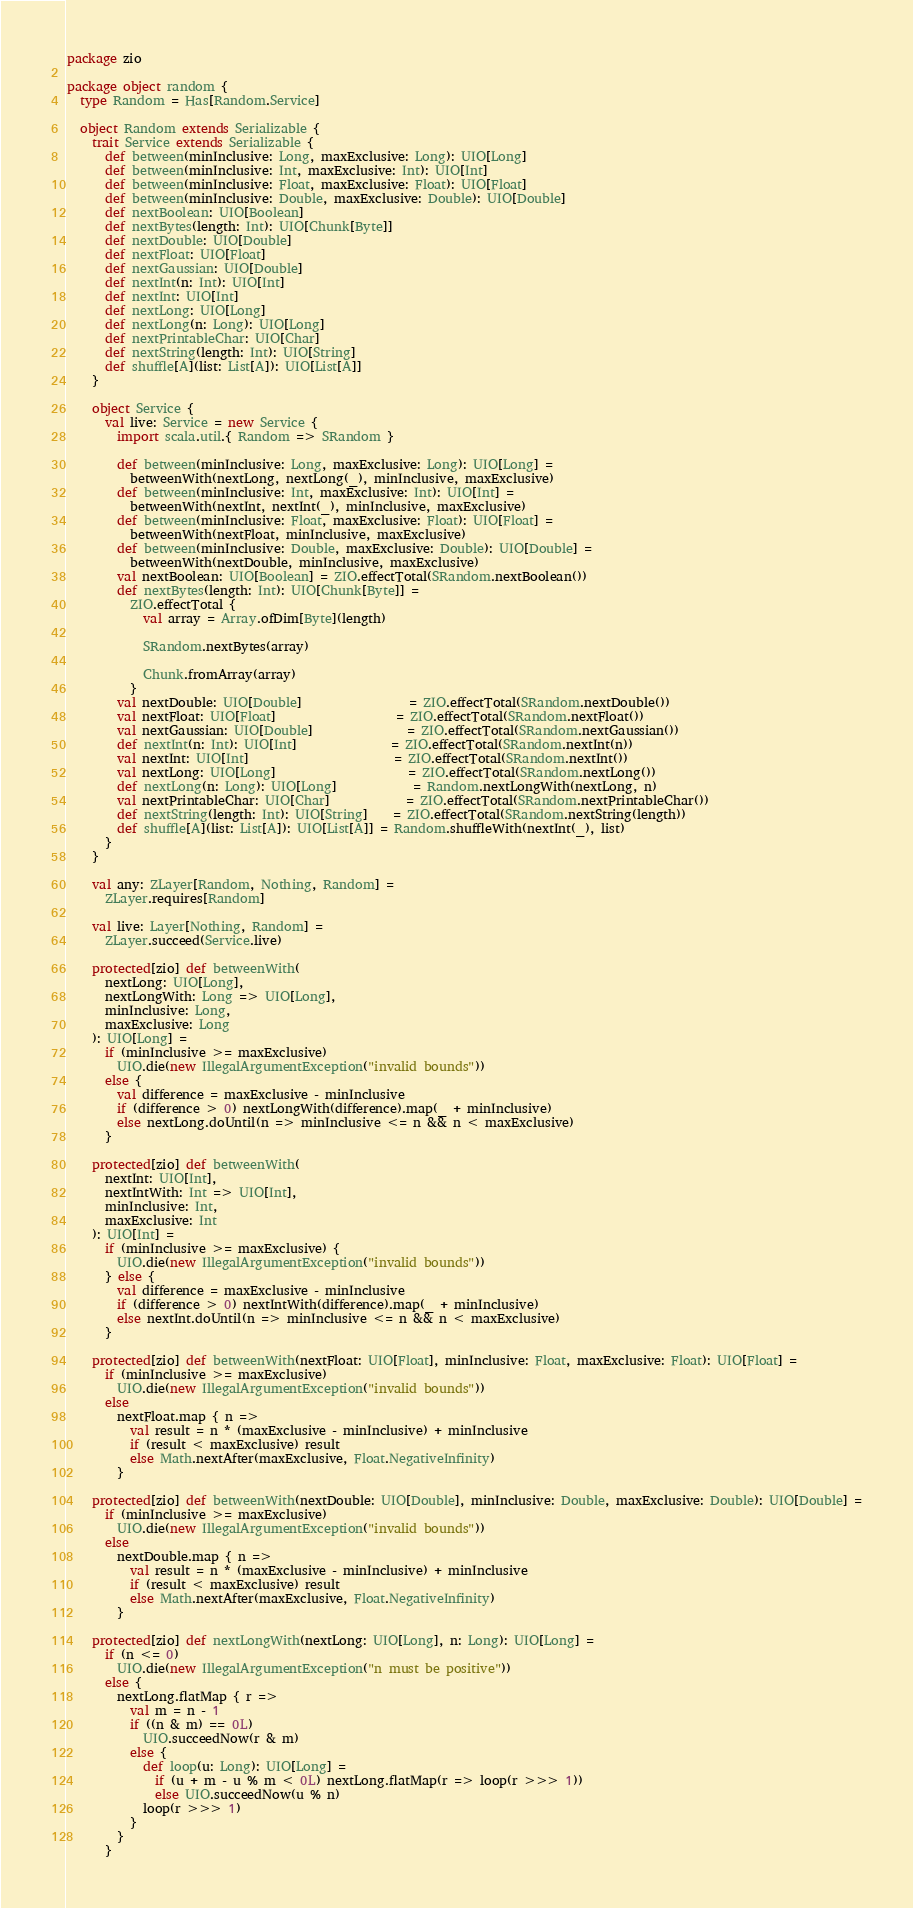<code> <loc_0><loc_0><loc_500><loc_500><_Scala_>package zio

package object random {
  type Random = Has[Random.Service]

  object Random extends Serializable {
    trait Service extends Serializable {
      def between(minInclusive: Long, maxExclusive: Long): UIO[Long]
      def between(minInclusive: Int, maxExclusive: Int): UIO[Int]
      def between(minInclusive: Float, maxExclusive: Float): UIO[Float]
      def between(minInclusive: Double, maxExclusive: Double): UIO[Double]
      def nextBoolean: UIO[Boolean]
      def nextBytes(length: Int): UIO[Chunk[Byte]]
      def nextDouble: UIO[Double]
      def nextFloat: UIO[Float]
      def nextGaussian: UIO[Double]
      def nextInt(n: Int): UIO[Int]
      def nextInt: UIO[Int]
      def nextLong: UIO[Long]
      def nextLong(n: Long): UIO[Long]
      def nextPrintableChar: UIO[Char]
      def nextString(length: Int): UIO[String]
      def shuffle[A](list: List[A]): UIO[List[A]]
    }

    object Service {
      val live: Service = new Service {
        import scala.util.{ Random => SRandom }

        def between(minInclusive: Long, maxExclusive: Long): UIO[Long] =
          betweenWith(nextLong, nextLong(_), minInclusive, maxExclusive)
        def between(minInclusive: Int, maxExclusive: Int): UIO[Int] =
          betweenWith(nextInt, nextInt(_), minInclusive, maxExclusive)
        def between(minInclusive: Float, maxExclusive: Float): UIO[Float] =
          betweenWith(nextFloat, minInclusive, maxExclusive)
        def between(minInclusive: Double, maxExclusive: Double): UIO[Double] =
          betweenWith(nextDouble, minInclusive, maxExclusive)
        val nextBoolean: UIO[Boolean] = ZIO.effectTotal(SRandom.nextBoolean())
        def nextBytes(length: Int): UIO[Chunk[Byte]] =
          ZIO.effectTotal {
            val array = Array.ofDim[Byte](length)

            SRandom.nextBytes(array)

            Chunk.fromArray(array)
          }
        val nextDouble: UIO[Double]                 = ZIO.effectTotal(SRandom.nextDouble())
        val nextFloat: UIO[Float]                   = ZIO.effectTotal(SRandom.nextFloat())
        val nextGaussian: UIO[Double]               = ZIO.effectTotal(SRandom.nextGaussian())
        def nextInt(n: Int): UIO[Int]               = ZIO.effectTotal(SRandom.nextInt(n))
        val nextInt: UIO[Int]                       = ZIO.effectTotal(SRandom.nextInt())
        val nextLong: UIO[Long]                     = ZIO.effectTotal(SRandom.nextLong())
        def nextLong(n: Long): UIO[Long]            = Random.nextLongWith(nextLong, n)
        val nextPrintableChar: UIO[Char]            = ZIO.effectTotal(SRandom.nextPrintableChar())
        def nextString(length: Int): UIO[String]    = ZIO.effectTotal(SRandom.nextString(length))
        def shuffle[A](list: List[A]): UIO[List[A]] = Random.shuffleWith(nextInt(_), list)
      }
    }

    val any: ZLayer[Random, Nothing, Random] =
      ZLayer.requires[Random]

    val live: Layer[Nothing, Random] =
      ZLayer.succeed(Service.live)

    protected[zio] def betweenWith(
      nextLong: UIO[Long],
      nextLongWith: Long => UIO[Long],
      minInclusive: Long,
      maxExclusive: Long
    ): UIO[Long] =
      if (minInclusive >= maxExclusive)
        UIO.die(new IllegalArgumentException("invalid bounds"))
      else {
        val difference = maxExclusive - minInclusive
        if (difference > 0) nextLongWith(difference).map(_ + minInclusive)
        else nextLong.doUntil(n => minInclusive <= n && n < maxExclusive)
      }

    protected[zio] def betweenWith(
      nextInt: UIO[Int],
      nextIntWith: Int => UIO[Int],
      minInclusive: Int,
      maxExclusive: Int
    ): UIO[Int] =
      if (minInclusive >= maxExclusive) {
        UIO.die(new IllegalArgumentException("invalid bounds"))
      } else {
        val difference = maxExclusive - minInclusive
        if (difference > 0) nextIntWith(difference).map(_ + minInclusive)
        else nextInt.doUntil(n => minInclusive <= n && n < maxExclusive)
      }

    protected[zio] def betweenWith(nextFloat: UIO[Float], minInclusive: Float, maxExclusive: Float): UIO[Float] =
      if (minInclusive >= maxExclusive)
        UIO.die(new IllegalArgumentException("invalid bounds"))
      else
        nextFloat.map { n =>
          val result = n * (maxExclusive - minInclusive) + minInclusive
          if (result < maxExclusive) result
          else Math.nextAfter(maxExclusive, Float.NegativeInfinity)
        }

    protected[zio] def betweenWith(nextDouble: UIO[Double], minInclusive: Double, maxExclusive: Double): UIO[Double] =
      if (minInclusive >= maxExclusive)
        UIO.die(new IllegalArgumentException("invalid bounds"))
      else
        nextDouble.map { n =>
          val result = n * (maxExclusive - minInclusive) + minInclusive
          if (result < maxExclusive) result
          else Math.nextAfter(maxExclusive, Float.NegativeInfinity)
        }

    protected[zio] def nextLongWith(nextLong: UIO[Long], n: Long): UIO[Long] =
      if (n <= 0)
        UIO.die(new IllegalArgumentException("n must be positive"))
      else {
        nextLong.flatMap { r =>
          val m = n - 1
          if ((n & m) == 0L)
            UIO.succeedNow(r & m)
          else {
            def loop(u: Long): UIO[Long] =
              if (u + m - u % m < 0L) nextLong.flatMap(r => loop(r >>> 1))
              else UIO.succeedNow(u % n)
            loop(r >>> 1)
          }
        }
      }
</code> 